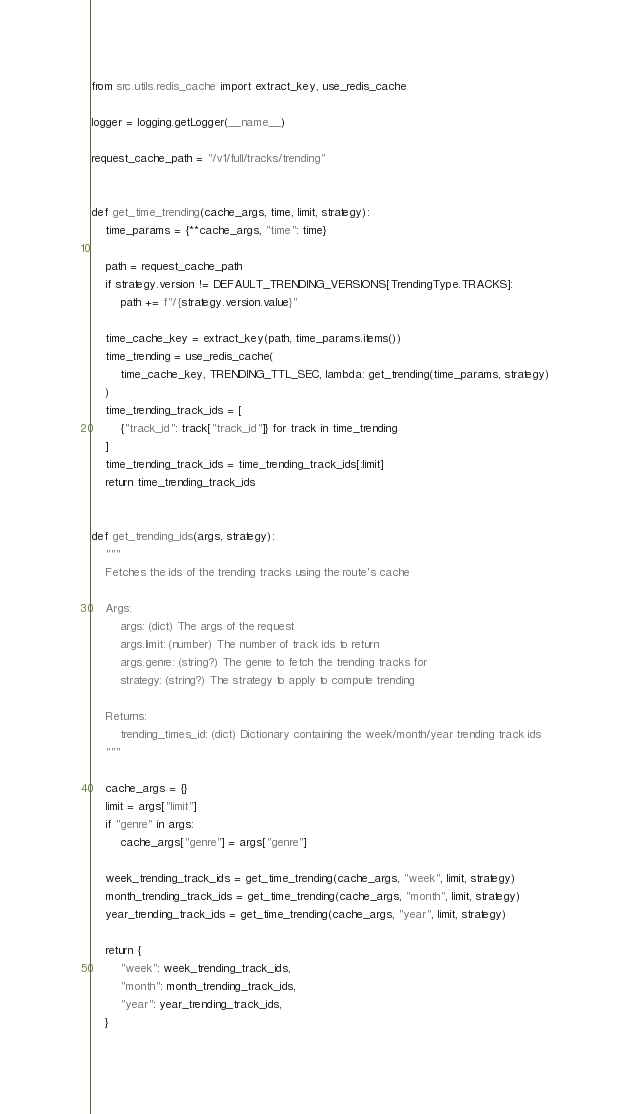Convert code to text. <code><loc_0><loc_0><loc_500><loc_500><_Python_>from src.utils.redis_cache import extract_key, use_redis_cache

logger = logging.getLogger(__name__)

request_cache_path = "/v1/full/tracks/trending"


def get_time_trending(cache_args, time, limit, strategy):
    time_params = {**cache_args, "time": time}

    path = request_cache_path
    if strategy.version != DEFAULT_TRENDING_VERSIONS[TrendingType.TRACKS]:
        path += f"/{strategy.version.value}"

    time_cache_key = extract_key(path, time_params.items())
    time_trending = use_redis_cache(
        time_cache_key, TRENDING_TTL_SEC, lambda: get_trending(time_params, strategy)
    )
    time_trending_track_ids = [
        {"track_id": track["track_id"]} for track in time_trending
    ]
    time_trending_track_ids = time_trending_track_ids[:limit]
    return time_trending_track_ids


def get_trending_ids(args, strategy):
    """
    Fetches the ids of the trending tracks using the route's cache

    Args:
        args: (dict) The args of the request
        args.limit: (number) The number of track ids to return
        args.genre: (string?) The genre to fetch the trending tracks for
        strategy: (string?) The strategy to apply to compute trending

    Returns:
        trending_times_id: (dict) Dictionary containing the week/month/year trending track ids
    """

    cache_args = {}
    limit = args["limit"]
    if "genre" in args:
        cache_args["genre"] = args["genre"]

    week_trending_track_ids = get_time_trending(cache_args, "week", limit, strategy)
    month_trending_track_ids = get_time_trending(cache_args, "month", limit, strategy)
    year_trending_track_ids = get_time_trending(cache_args, "year", limit, strategy)

    return {
        "week": week_trending_track_ids,
        "month": month_trending_track_ids,
        "year": year_trending_track_ids,
    }
</code> 